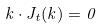Convert formula to latex. <formula><loc_0><loc_0><loc_500><loc_500>k \cdot J _ { t } ( k ) = 0</formula> 